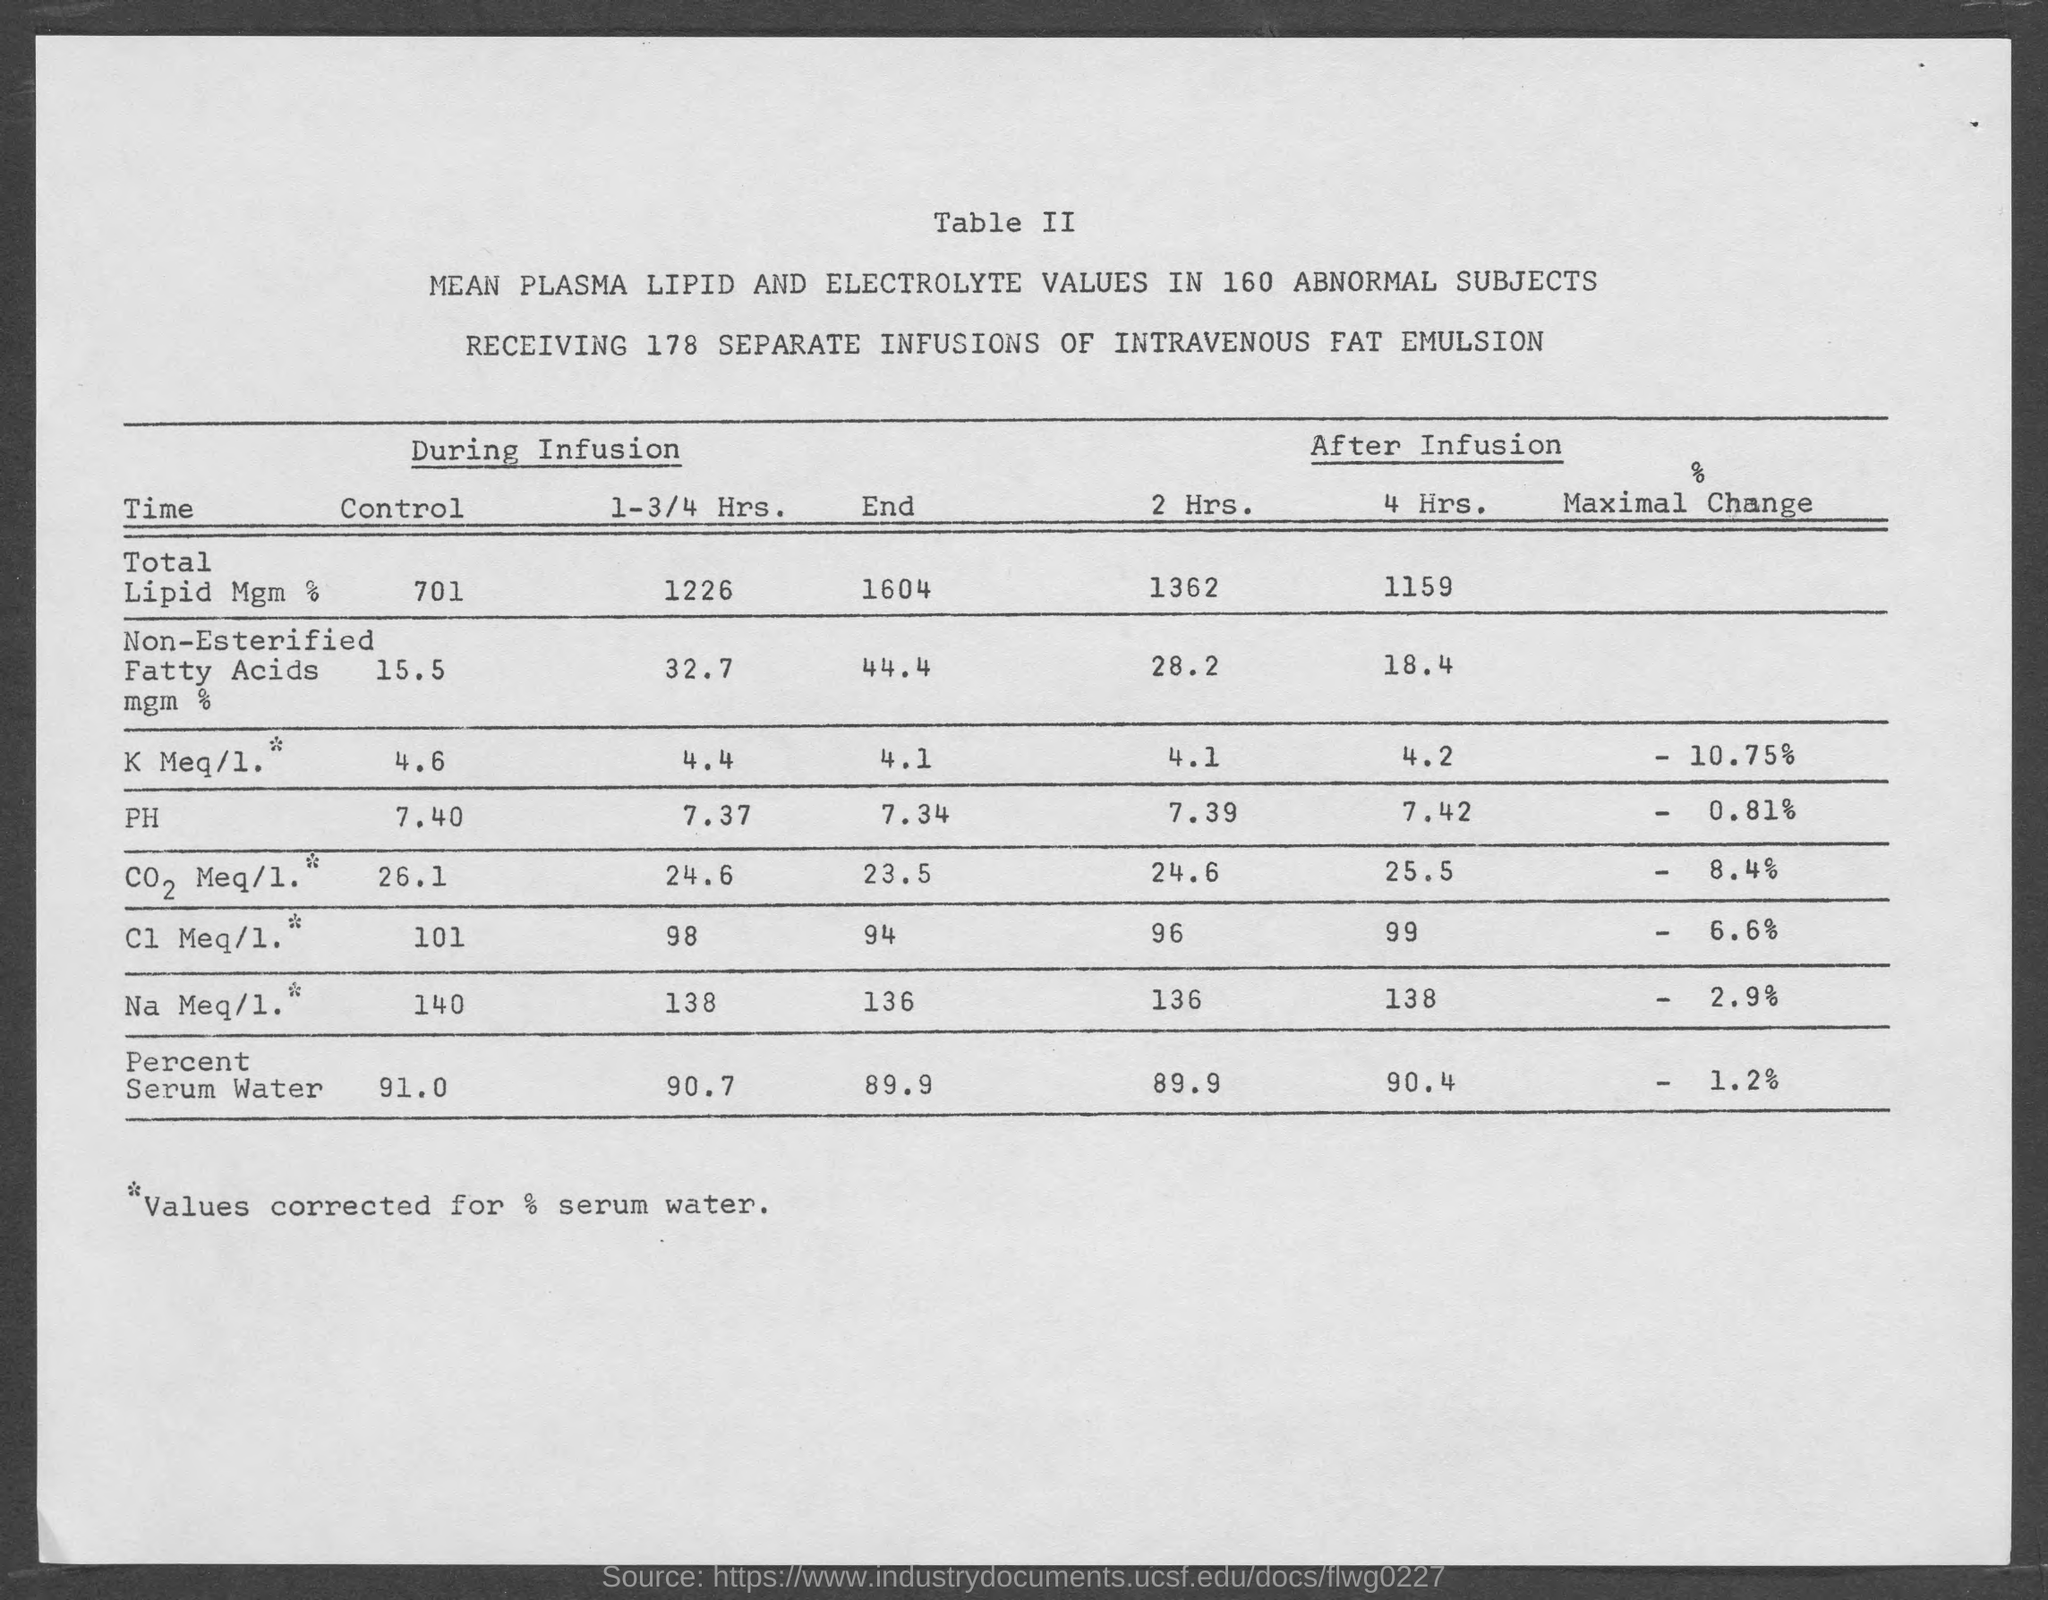How many separate infusions of intravenous fat emulsion is being received?
Give a very brief answer. 178. 